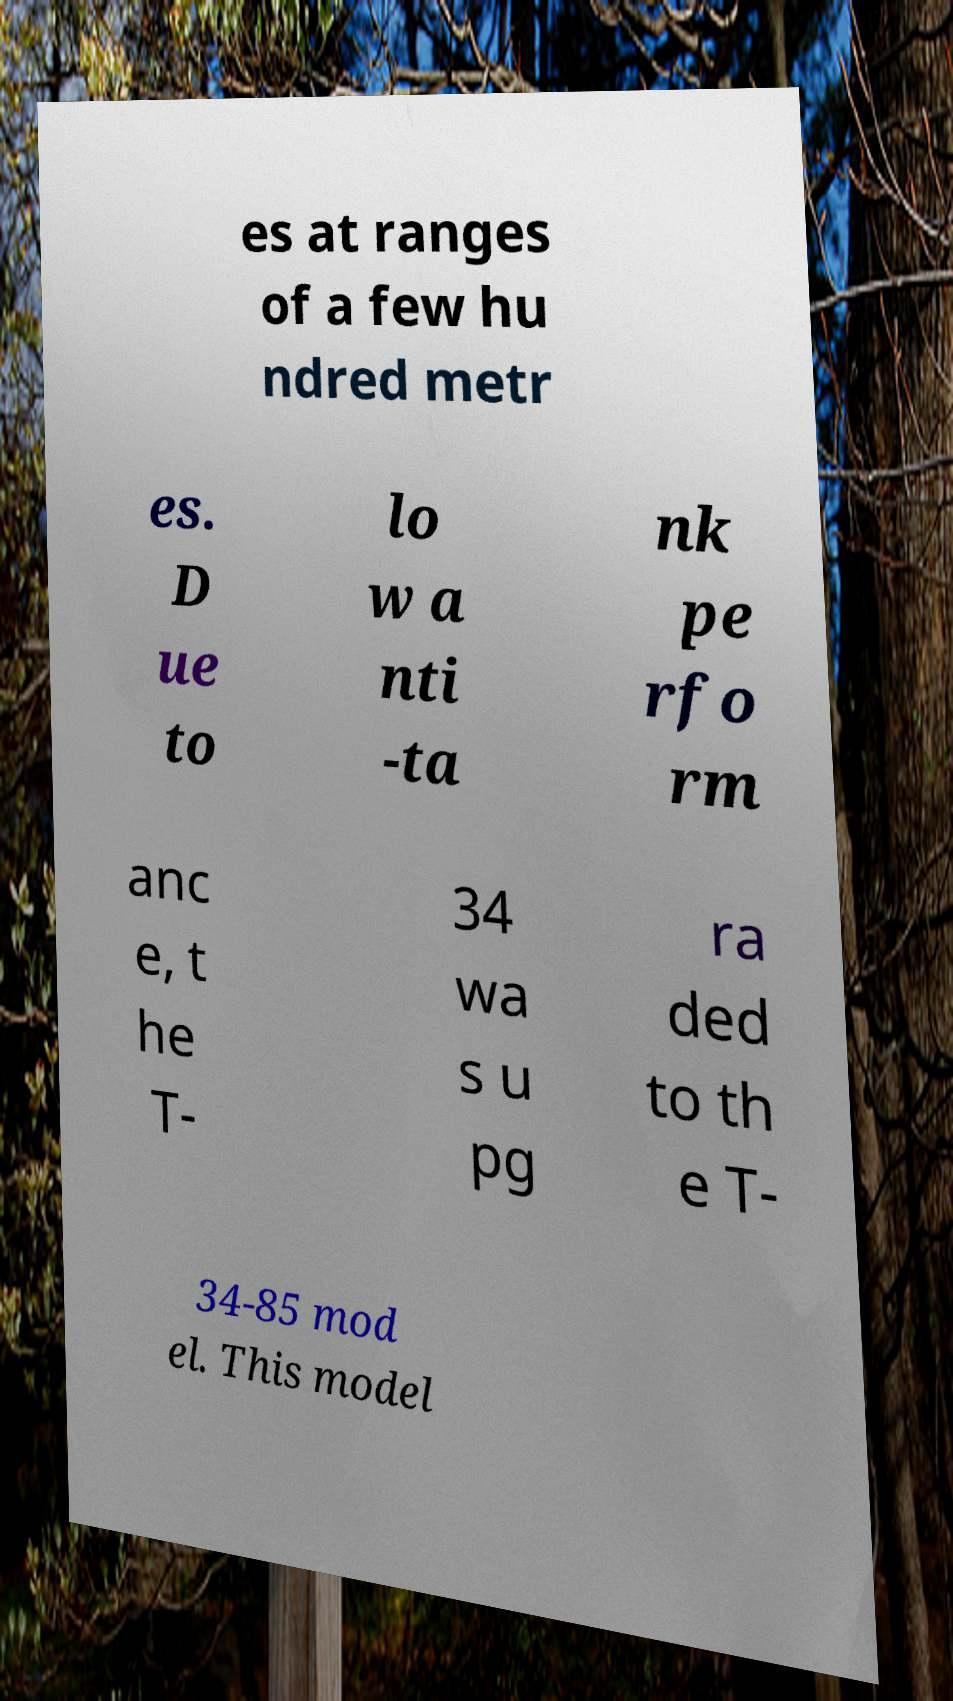Can you read and provide the text displayed in the image?This photo seems to have some interesting text. Can you extract and type it out for me? es at ranges of a few hu ndred metr es. D ue to lo w a nti -ta nk pe rfo rm anc e, t he T- 34 wa s u pg ra ded to th e T- 34-85 mod el. This model 